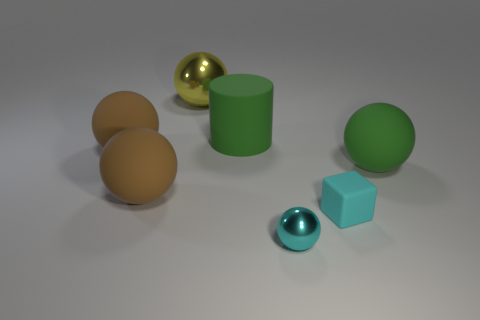Does the matte cube have the same color as the tiny ball?
Keep it short and to the point. Yes. Is the number of tiny objects greater than the number of matte spheres?
Offer a very short reply. No. Is there anything else that is the same color as the rubber cylinder?
Offer a very short reply. Yes. Is the green cylinder made of the same material as the large green sphere?
Offer a very short reply. Yes. Are there fewer large green balls than big gray objects?
Keep it short and to the point. No. Is the shape of the cyan matte object the same as the big yellow shiny thing?
Ensure brevity in your answer.  No. The rubber block is what color?
Provide a short and direct response. Cyan. How many other objects are there of the same material as the large yellow object?
Provide a succinct answer. 1. How many green things are large metal cubes or big cylinders?
Offer a very short reply. 1. There is a metallic object that is behind the cyan metal ball; is its shape the same as the small cyan object right of the cyan ball?
Keep it short and to the point. No. 